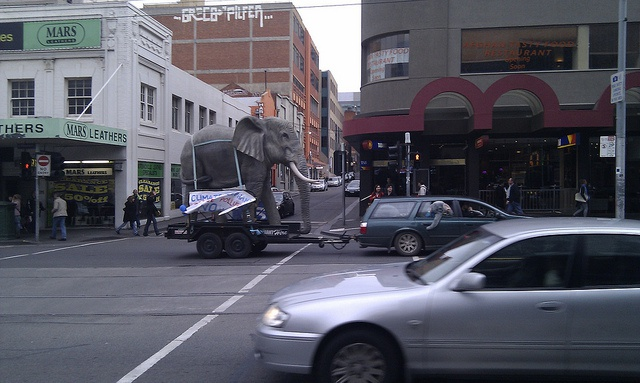Describe the objects in this image and their specific colors. I can see car in darkgray, black, gray, and lavender tones, elephant in darkgray, gray, and black tones, car in darkgray, black, and gray tones, people in darkgray, black, gray, navy, and darkblue tones, and traffic light in darkgray, black, gray, and darkgreen tones in this image. 